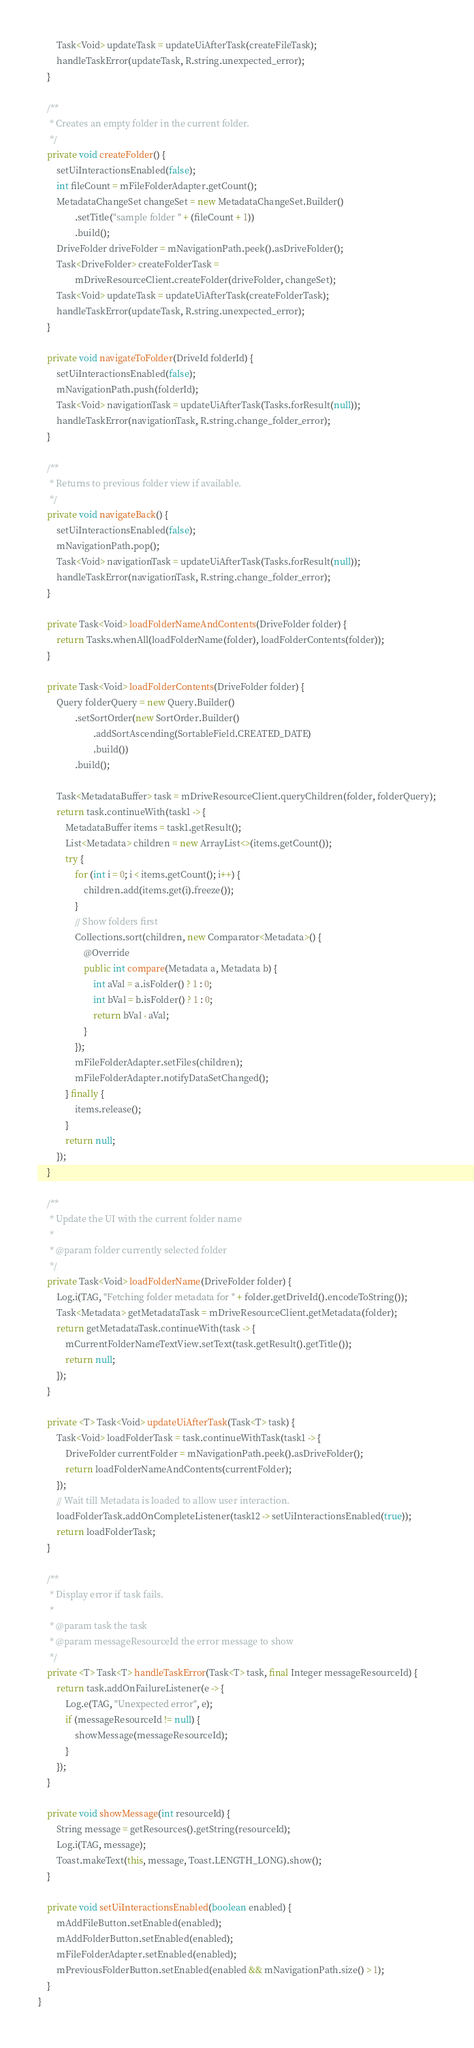<code> <loc_0><loc_0><loc_500><loc_500><_Java_>        Task<Void> updateTask = updateUiAfterTask(createFileTask);
        handleTaskError(updateTask, R.string.unexpected_error);
    }

    /**
     * Creates an empty folder in the current folder.
     */
    private void createFolder() {
        setUiInteractionsEnabled(false);
        int fileCount = mFileFolderAdapter.getCount();
        MetadataChangeSet changeSet = new MetadataChangeSet.Builder()
                .setTitle("sample folder " + (fileCount + 1))
                .build();
        DriveFolder driveFolder = mNavigationPath.peek().asDriveFolder();
        Task<DriveFolder> createFolderTask =
                mDriveResourceClient.createFolder(driveFolder, changeSet);
        Task<Void> updateTask = updateUiAfterTask(createFolderTask);
        handleTaskError(updateTask, R.string.unexpected_error);
    }

    private void navigateToFolder(DriveId folderId) {
        setUiInteractionsEnabled(false);
        mNavigationPath.push(folderId);
        Task<Void> navigationTask = updateUiAfterTask(Tasks.forResult(null));
        handleTaskError(navigationTask, R.string.change_folder_error);
    }

    /**
     * Returns to previous folder view if available.
     */
    private void navigateBack() {
        setUiInteractionsEnabled(false);
        mNavigationPath.pop();
        Task<Void> navigationTask = updateUiAfterTask(Tasks.forResult(null));
        handleTaskError(navigationTask, R.string.change_folder_error);
    }

    private Task<Void> loadFolderNameAndContents(DriveFolder folder) {
        return Tasks.whenAll(loadFolderName(folder), loadFolderContents(folder));
    }

    private Task<Void> loadFolderContents(DriveFolder folder) {
        Query folderQuery = new Query.Builder()
                .setSortOrder(new SortOrder.Builder()
                        .addSortAscending(SortableField.CREATED_DATE)
                        .build())
                .build();

        Task<MetadataBuffer> task = mDriveResourceClient.queryChildren(folder, folderQuery);
        return task.continueWith(task1 -> {
            MetadataBuffer items = task1.getResult();
            List<Metadata> children = new ArrayList<>(items.getCount());
            try {
                for (int i = 0; i < items.getCount(); i++) {
                    children.add(items.get(i).freeze());
                }
                // Show folders first
                Collections.sort(children, new Comparator<Metadata>() {
                    @Override
                    public int compare(Metadata a, Metadata b) {
                        int aVal = a.isFolder() ? 1 : 0;
                        int bVal = b.isFolder() ? 1 : 0;
                        return bVal - aVal;
                    }
                });
                mFileFolderAdapter.setFiles(children);
                mFileFolderAdapter.notifyDataSetChanged();
            } finally {
                items.release();
            }
            return null;
        });
    }

    /**
     * Update the UI with the current folder name
     *
     * @param folder currently selected folder
     */
    private Task<Void> loadFolderName(DriveFolder folder) {
        Log.i(TAG, "Fetching folder metadata for " + folder.getDriveId().encodeToString());
        Task<Metadata> getMetadataTask = mDriveResourceClient.getMetadata(folder);
        return getMetadataTask.continueWith(task -> {
            mCurrentFolderNameTextView.setText(task.getResult().getTitle());
            return null;
        });
    }

    private <T> Task<Void> updateUiAfterTask(Task<T> task) {
        Task<Void> loadFolderTask = task.continueWithTask(task1 -> {
            DriveFolder currentFolder = mNavigationPath.peek().asDriveFolder();
            return loadFolderNameAndContents(currentFolder);
        });
        // Wait till Metadata is loaded to allow user interaction.
        loadFolderTask.addOnCompleteListener(task12 -> setUiInteractionsEnabled(true));
        return loadFolderTask;
    }

    /**
     * Display error if task fails.
     *
     * @param task the task
     * @param messageResourceId the error message to show
     */
    private <T> Task<T> handleTaskError(Task<T> task, final Integer messageResourceId) {
        return task.addOnFailureListener(e -> {
            Log.e(TAG, "Unexpected error", e);
            if (messageResourceId != null) {
                showMessage(messageResourceId);
            }
        });
    }

    private void showMessage(int resourceId) {
        String message = getResources().getString(resourceId);
        Log.i(TAG, message);
        Toast.makeText(this, message, Toast.LENGTH_LONG).show();
    }

    private void setUiInteractionsEnabled(boolean enabled) {
        mAddFileButton.setEnabled(enabled);
        mAddFolderButton.setEnabled(enabled);
        mFileFolderAdapter.setEnabled(enabled);
        mPreviousFolderButton.setEnabled(enabled && mNavigationPath.size() > 1);
    }
}</code> 